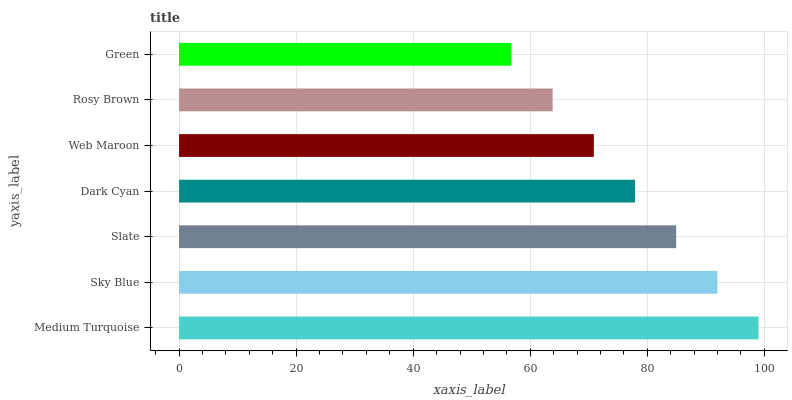Is Green the minimum?
Answer yes or no. Yes. Is Medium Turquoise the maximum?
Answer yes or no. Yes. Is Sky Blue the minimum?
Answer yes or no. No. Is Sky Blue the maximum?
Answer yes or no. No. Is Medium Turquoise greater than Sky Blue?
Answer yes or no. Yes. Is Sky Blue less than Medium Turquoise?
Answer yes or no. Yes. Is Sky Blue greater than Medium Turquoise?
Answer yes or no. No. Is Medium Turquoise less than Sky Blue?
Answer yes or no. No. Is Dark Cyan the high median?
Answer yes or no. Yes. Is Dark Cyan the low median?
Answer yes or no. Yes. Is Web Maroon the high median?
Answer yes or no. No. Is Medium Turquoise the low median?
Answer yes or no. No. 